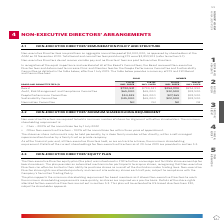According to Woolworths Limited's financial document, What was the total board and committee fees paid during F19? According to the financial document, $2,859,903. The relevant text states: "otal board and committee fees paid during F19 were $2,859,903 (refer to section 5.1)...." Also, What is the F19 fee for a member of the People Performance Committee? According to the financial document, $27,265. The relevant text states: "2,500 People Performance Committee $54,525 $65,000 $27,265 $32,500 Sustainability Committee $45,000 $65,000 $22,500 $32,500 Nomination Committee Nil Nil Nil Ni..." Also, What is the value of the aggregate annual fee pool used to pay non-executive Director fees? According to the financial document, $4,000,000. The relevant text states: "fees are paid from an aggregate annual fee pool of $4,000,000, as approved by shareholders at the AGM on 18 November 2010. Total board and committee fees paid du..." Also, can you calculate: What is the percentage increase for the fees paid to the Chair of Sustainability Committee between F19 and F20? To answer this question, I need to perform calculations using the financial data. The calculation is: (65,000 - 45,000)/ 45,000 , which equals 44.44 (percentage). This is based on the information: "Audit, Risk Management and Compliance Committee $65,000 $65,000 $32,500 $32,500 People Performance Committee $54,525 $65,000 $27,265 $32,500 Sustainability $65,000 $27,265 $32,500 Sustainability Commi..." The key data points involved are: 45,000, 65,000. Also, can you calculate: What is the nominal difference for the fees paid in F19 and F20 to a member in the board? I cannot find a specific answer to this question in the financial document. Also, can you calculate: What is the difference between the fees paid to a member in the board compared to a member in the sustainability committee in F19? Based on the calculation: 254,990 - 22,500 , the result is 232490. This is based on the information: "Board $790,531 $790,531 $254,990 $254,990 Audit, Risk Management and Compliance Committee $65,000 $65,000 $32,500 $32,500 People Per $32,500 Sustainability Committee $45,000 $65,000 $22,500 $32,500 No..." The key data points involved are: 22,500, 254,990. 